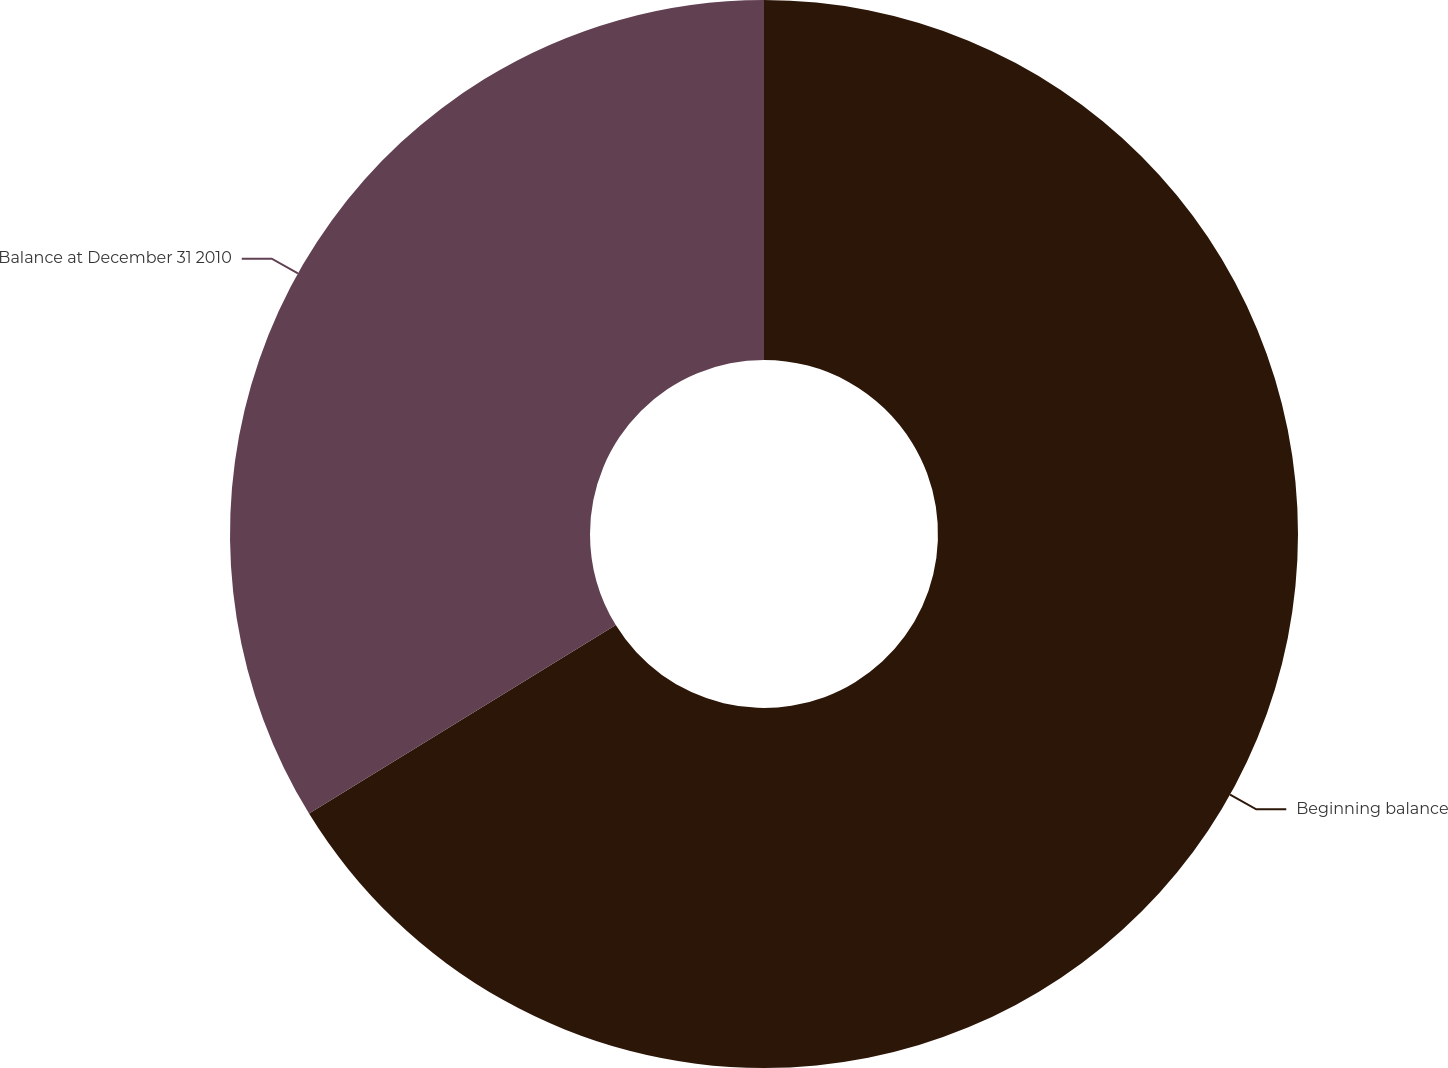Convert chart. <chart><loc_0><loc_0><loc_500><loc_500><pie_chart><fcel>Beginning balance<fcel>Balance at December 31 2010<nl><fcel>66.23%<fcel>33.77%<nl></chart> 